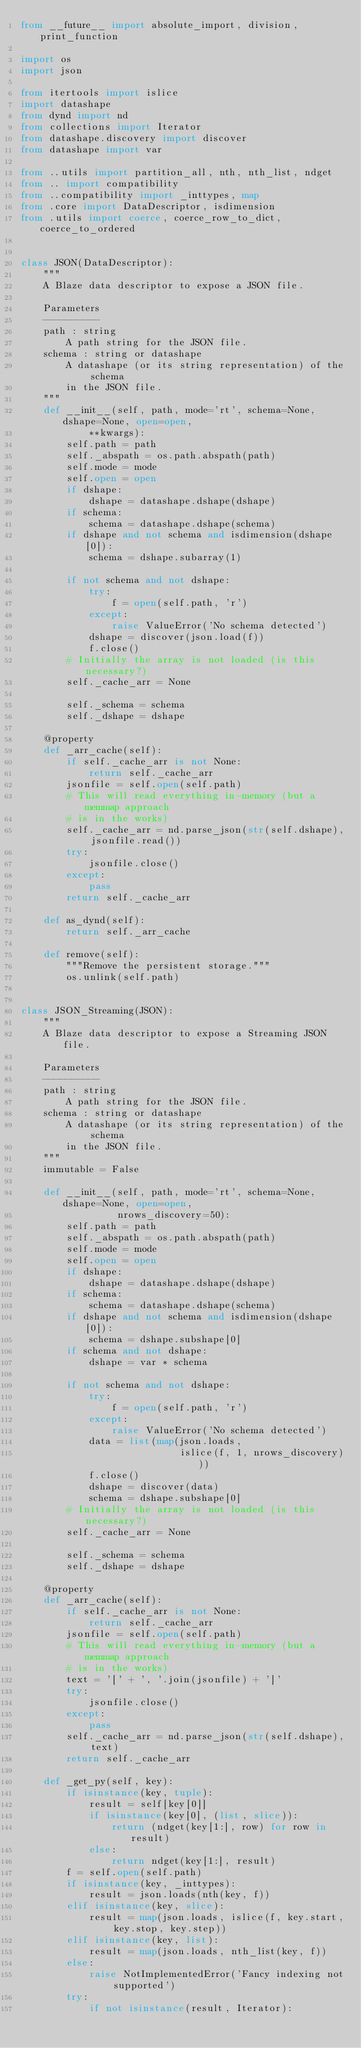<code> <loc_0><loc_0><loc_500><loc_500><_Python_>from __future__ import absolute_import, division, print_function

import os
import json

from itertools import islice
import datashape
from dynd import nd
from collections import Iterator
from datashape.discovery import discover
from datashape import var

from ..utils import partition_all, nth, nth_list, ndget
from .. import compatibility
from ..compatibility import _inttypes, map
from .core import DataDescriptor, isdimension
from .utils import coerce, coerce_row_to_dict, coerce_to_ordered


class JSON(DataDescriptor):
    """
    A Blaze data descriptor to expose a JSON file.

    Parameters
    ----------
    path : string
        A path string for the JSON file.
    schema : string or datashape
        A datashape (or its string representation) of the schema
        in the JSON file.
    """
    def __init__(self, path, mode='rt', schema=None, dshape=None, open=open,
            **kwargs):
        self.path = path
        self._abspath = os.path.abspath(path)
        self.mode = mode
        self.open = open
        if dshape:
            dshape = datashape.dshape(dshape)
        if schema:
            schema = datashape.dshape(schema)
        if dshape and not schema and isdimension(dshape[0]):
            schema = dshape.subarray(1)

        if not schema and not dshape:
            try:
                f = open(self.path, 'r')
            except:
                raise ValueError('No schema detected')
            dshape = discover(json.load(f))
            f.close()
        # Initially the array is not loaded (is this necessary?)
        self._cache_arr = None

        self._schema = schema
        self._dshape = dshape

    @property
    def _arr_cache(self):
        if self._cache_arr is not None:
            return self._cache_arr
        jsonfile = self.open(self.path)
        # This will read everything in-memory (but a memmap approach
        # is in the works)
        self._cache_arr = nd.parse_json(str(self.dshape), jsonfile.read())
        try:
            jsonfile.close()
        except:
            pass
        return self._cache_arr

    def as_dynd(self):
        return self._arr_cache

    def remove(self):
        """Remove the persistent storage."""
        os.unlink(self.path)


class JSON_Streaming(JSON):
    """
    A Blaze data descriptor to expose a Streaming JSON file.

    Parameters
    ----------
    path : string
        A path string for the JSON file.
    schema : string or datashape
        A datashape (or its string representation) of the schema
        in the JSON file.
    """
    immutable = False

    def __init__(self, path, mode='rt', schema=None, dshape=None, open=open,
                 nrows_discovery=50):
        self.path = path
        self._abspath = os.path.abspath(path)
        self.mode = mode
        self.open = open
        if dshape:
            dshape = datashape.dshape(dshape)
        if schema:
            schema = datashape.dshape(schema)
        if dshape and not schema and isdimension(dshape[0]):
            schema = dshape.subshape[0]
        if schema and not dshape:
            dshape = var * schema

        if not schema and not dshape:
            try:
                f = open(self.path, 'r')
            except:
                raise ValueError('No schema detected')
            data = list(map(json.loads,
                            islice(f, 1, nrows_discovery)))
            f.close()
            dshape = discover(data)
            schema = dshape.subshape[0]
        # Initially the array is not loaded (is this necessary?)
        self._cache_arr = None

        self._schema = schema
        self._dshape = dshape

    @property
    def _arr_cache(self):
        if self._cache_arr is not None:
            return self._cache_arr
        jsonfile = self.open(self.path)
        # This will read everything in-memory (but a memmap approach
        # is in the works)
        text = '[' + ', '.join(jsonfile) + ']'
        try:
            jsonfile.close()
        except:
            pass
        self._cache_arr = nd.parse_json(str(self.dshape), text)
        return self._cache_arr

    def _get_py(self, key):
        if isinstance(key, tuple):
            result = self[key[0]]
            if isinstance(key[0], (list, slice)):
                return (ndget(key[1:], row) for row in result)
            else:
                return ndget(key[1:], result)
        f = self.open(self.path)
        if isinstance(key, _inttypes):
            result = json.loads(nth(key, f))
        elif isinstance(key, slice):
            result = map(json.loads, islice(f, key.start, key.stop, key.step))
        elif isinstance(key, list):
            result = map(json.loads, nth_list(key, f))
        else:
            raise NotImplementedError('Fancy indexing not supported')
        try:
            if not isinstance(result, Iterator):</code> 